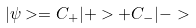<formula> <loc_0><loc_0><loc_500><loc_500>| \psi > = C _ { + } | + > + C _ { - } | - ></formula> 